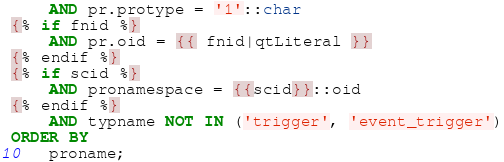<code> <loc_0><loc_0><loc_500><loc_500><_SQL_>    AND pr.protype = '1'::char
{% if fnid %}
    AND pr.oid = {{ fnid|qtLiteral }}
{% endif %}
{% if scid %}
    AND pronamespace = {{scid}}::oid
{% endif %}
    AND typname NOT IN ('trigger', 'event_trigger')
ORDER BY
    proname;
</code> 